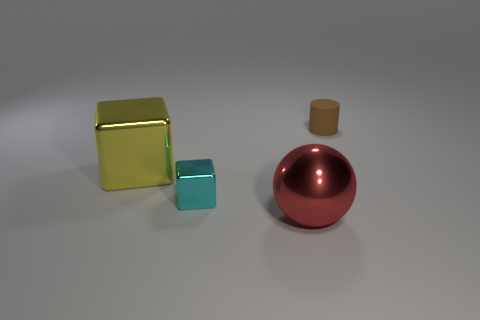How many objects are small green cylinders or yellow blocks?
Provide a short and direct response. 1. Is the shape of the brown object the same as the big shiny object that is left of the large red shiny object?
Offer a very short reply. No. There is a tiny thing in front of the rubber cylinder; what is its shape?
Your answer should be very brief. Cube. Is the tiny metallic object the same shape as the big yellow object?
Your response must be concise. Yes. There is another thing that is the same shape as the yellow shiny object; what is its size?
Offer a very short reply. Small. Is the size of the thing to the right of the red sphere the same as the red shiny sphere?
Offer a very short reply. No. What size is the thing that is in front of the brown rubber thing and behind the tiny cube?
Make the answer very short. Large. What number of tiny matte things are the same color as the large block?
Ensure brevity in your answer.  0. Are there the same number of red metallic spheres that are to the left of the big yellow thing and small rubber cylinders?
Offer a very short reply. No. What color is the rubber thing?
Keep it short and to the point. Brown. 